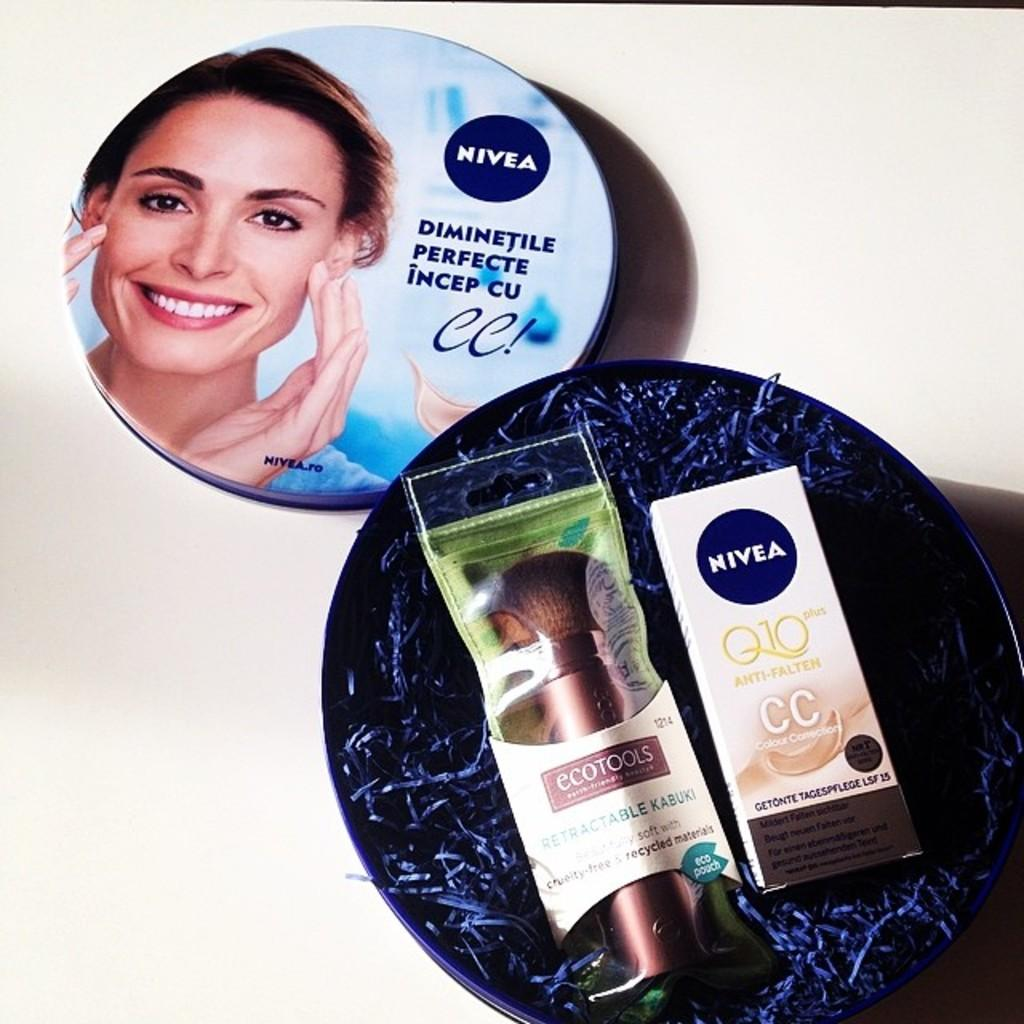<image>
Present a compact description of the photo's key features. Giftbox of Nivea prodcuts featuring face creams and cleaning products. 